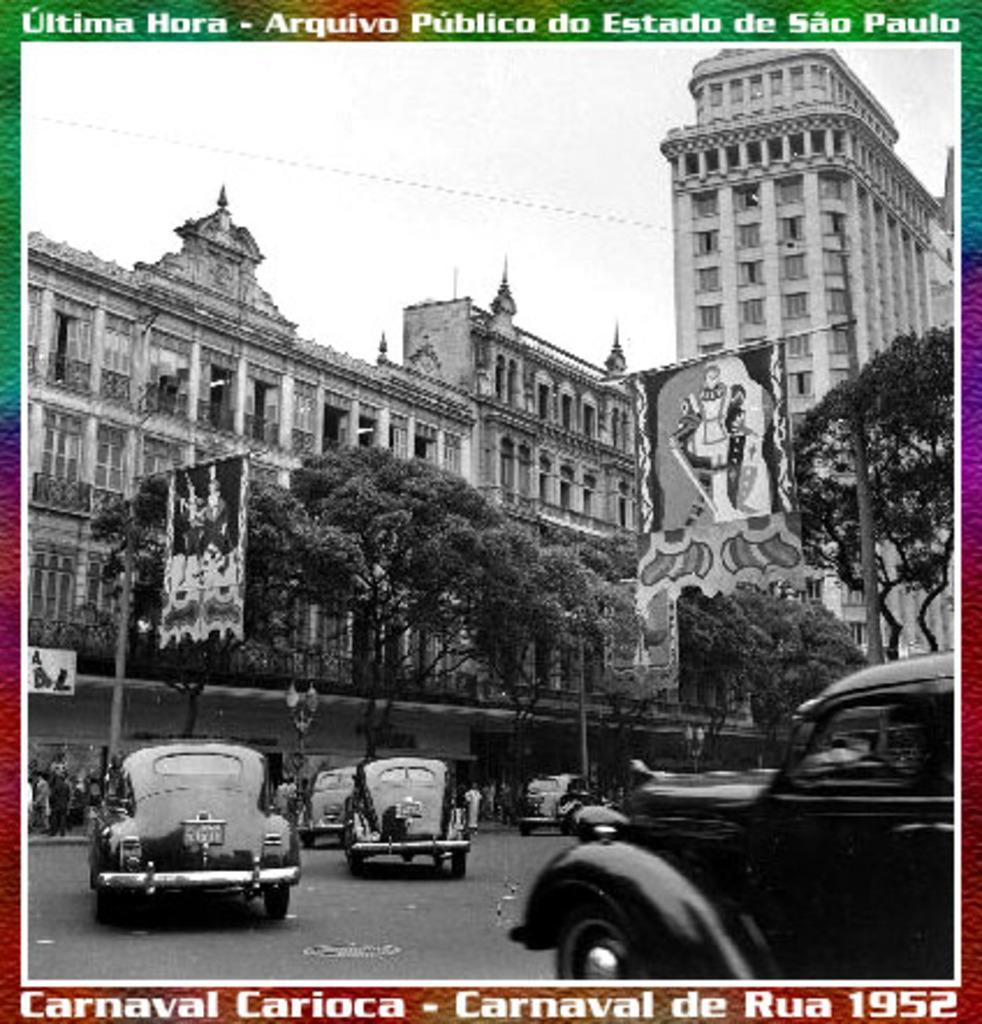How would you summarize this image in a sentence or two? This is a black and white image. In this image we can see buildings, trees, poles, cars and persons. In the background there is sky. At the top and bottom of the image we can see text. 